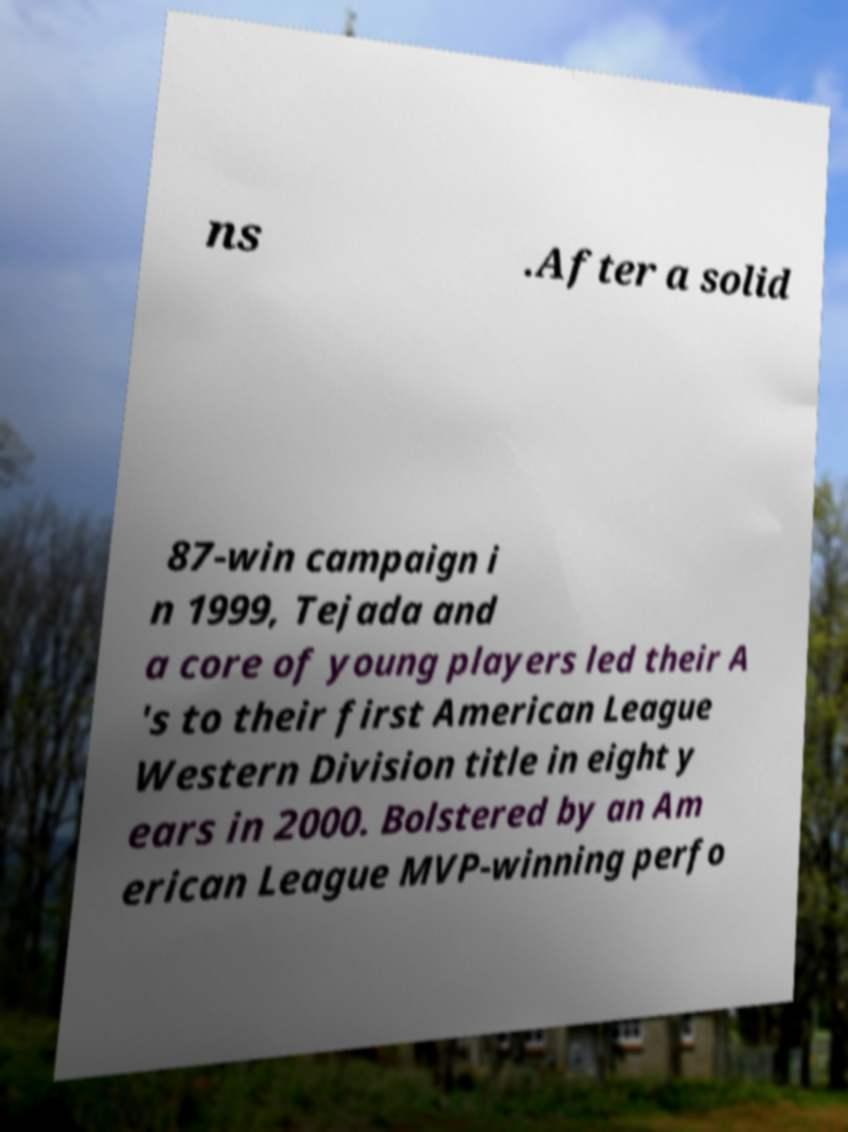Please identify and transcribe the text found in this image. ns .After a solid 87-win campaign i n 1999, Tejada and a core of young players led their A 's to their first American League Western Division title in eight y ears in 2000. Bolstered by an Am erican League MVP-winning perfo 